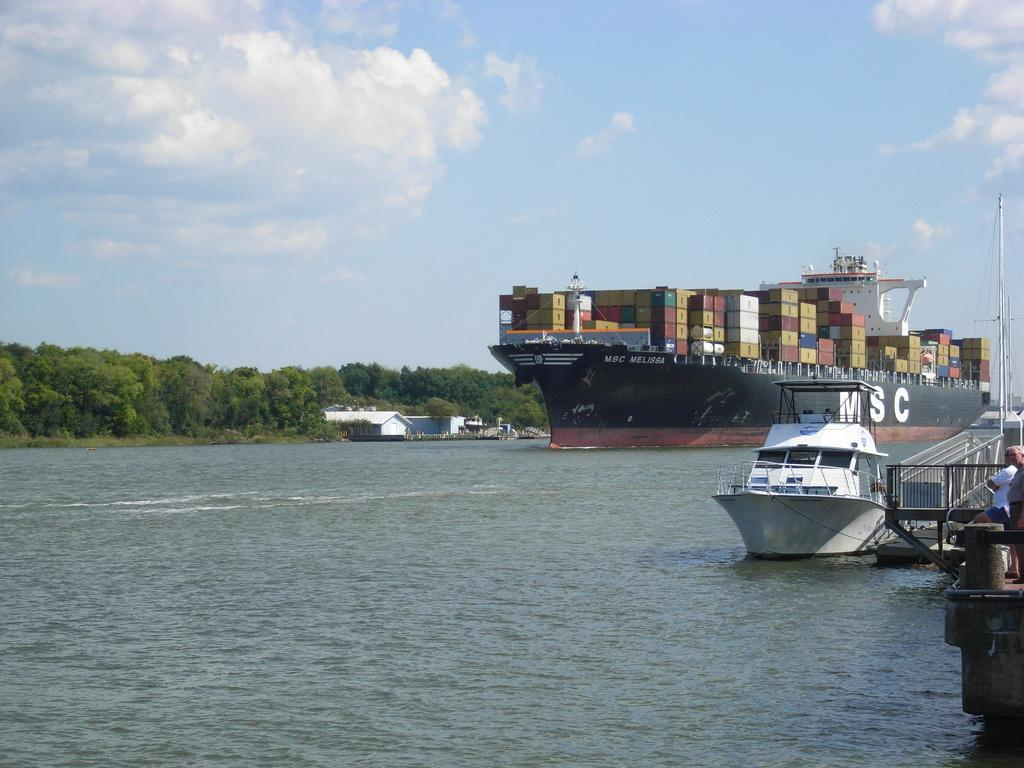How many people are in the image? There are two people standing on the right side of the image. What can be seen on the water in the image? There are ships visible on the water. What is located in the background of the image? There is a shed and trees in the background of the image. What is visible in the sky in the image? The sky is visible in the background of the image. What type of skin is visible on the girl in the image? There is no girl present in the image, so there is no skin to describe. 